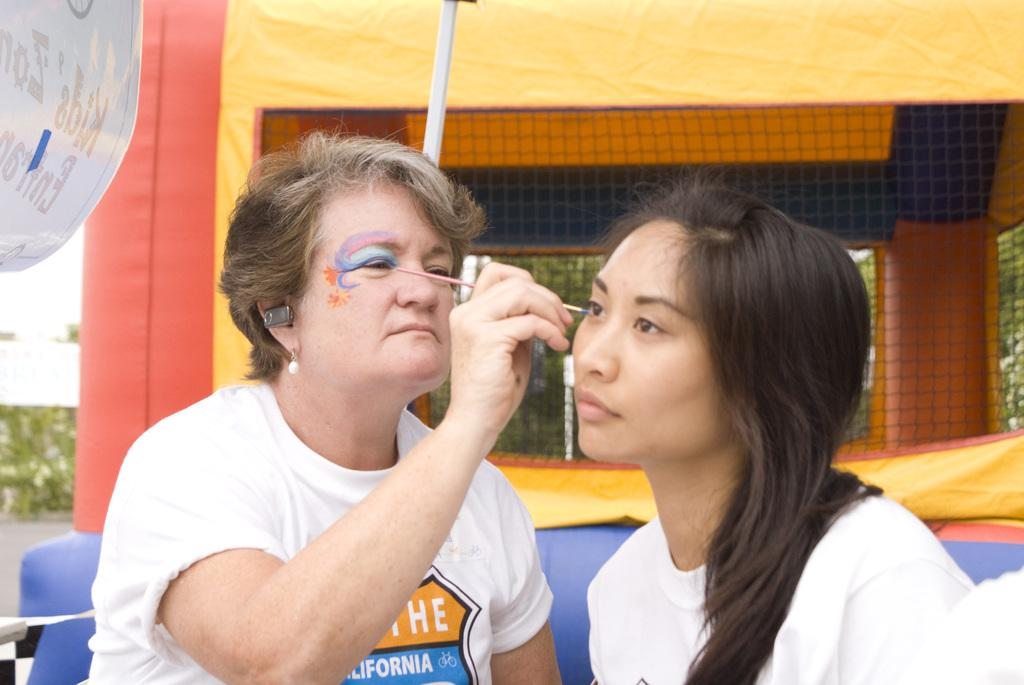What is the woman in the image holding? The woman is holding a brush in the image. What is the woman doing with the brush? The woman is painting on another woman's face. What other objects can be seen in the image? There is a rod, a banner, a mesh, and a tent in the image. What can be seen in the background of the image? Leaves are visible in the background of the image. Can you see any farm animals in the image? There are no farm animals present in the image. What type of iron is being used to create the mesh in the image? There is no iron visible in the image; it is a mesh made of a different material. 